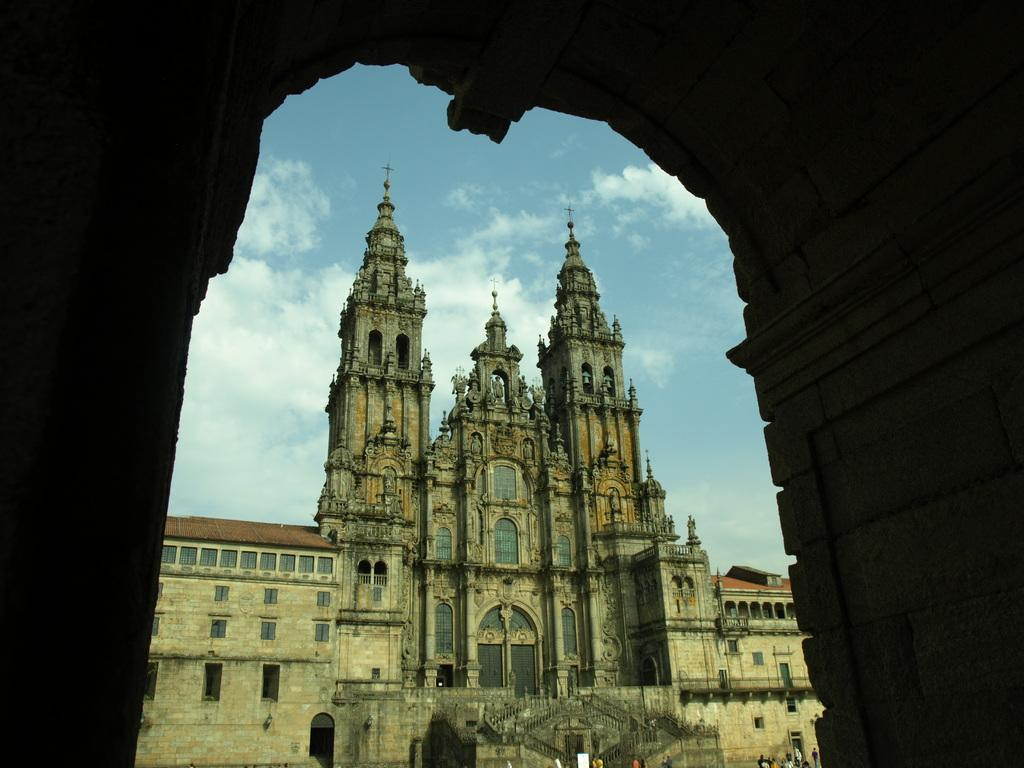What type of structure can be seen in the background of the image? There is a building in the background of the image. What is located in the foreground of the image? There is an entrance in the foreground of the image. How would you describe the sky in the image? The sky is cloudy in the image. Can you tell if there are any people in the image? Yes, there are people present in the image. What type of flower is being represented by the people in the image? There is no flower being represented by the people in the image. What sense is being stimulated by the cloudy sky in the image? The cloudy sky in the image does not stimulate a specific sense; it is a visual element. 